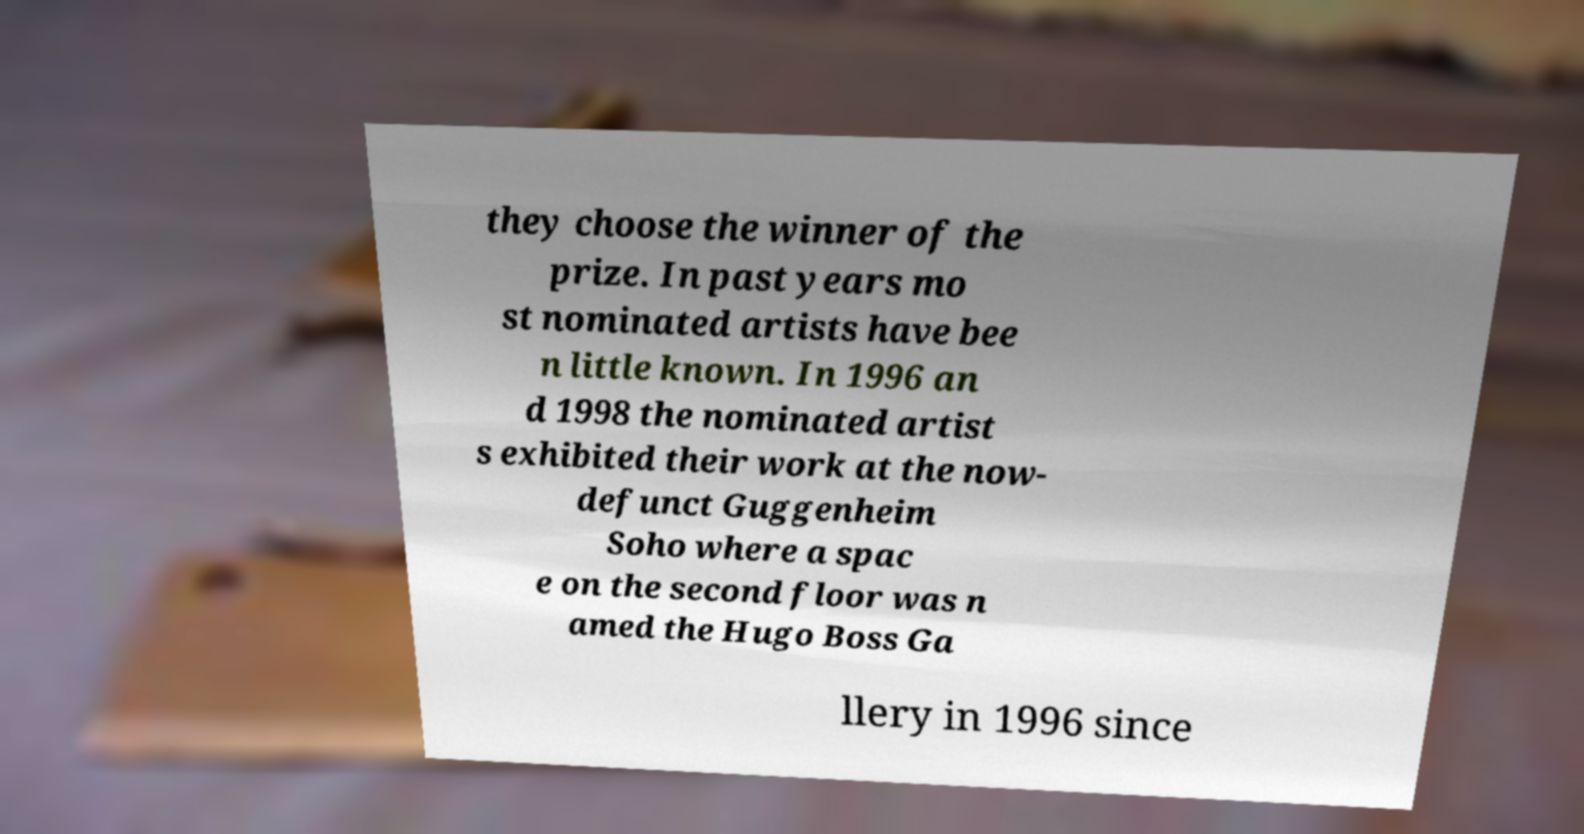Can you accurately transcribe the text from the provided image for me? they choose the winner of the prize. In past years mo st nominated artists have bee n little known. In 1996 an d 1998 the nominated artist s exhibited their work at the now- defunct Guggenheim Soho where a spac e on the second floor was n amed the Hugo Boss Ga llery in 1996 since 